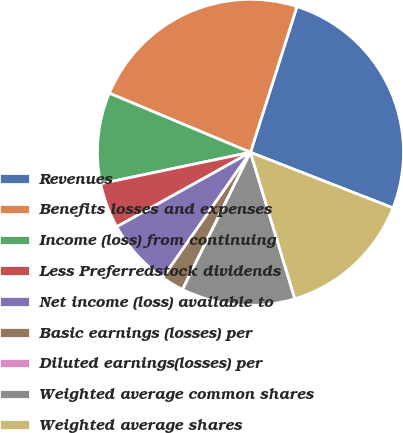Convert chart to OTSL. <chart><loc_0><loc_0><loc_500><loc_500><pie_chart><fcel>Revenues<fcel>Benefits losses and expenses<fcel>Income (loss) from continuing<fcel>Less Preferredstock dividends<fcel>Net income (loss) available to<fcel>Basic earnings (losses) per<fcel>Diluted earnings(losses) per<fcel>Weighted average common shares<fcel>Weighted average shares<nl><fcel>26.0%<fcel>23.6%<fcel>9.6%<fcel>4.8%<fcel>7.2%<fcel>2.4%<fcel>0.0%<fcel>12.0%<fcel>14.4%<nl></chart> 